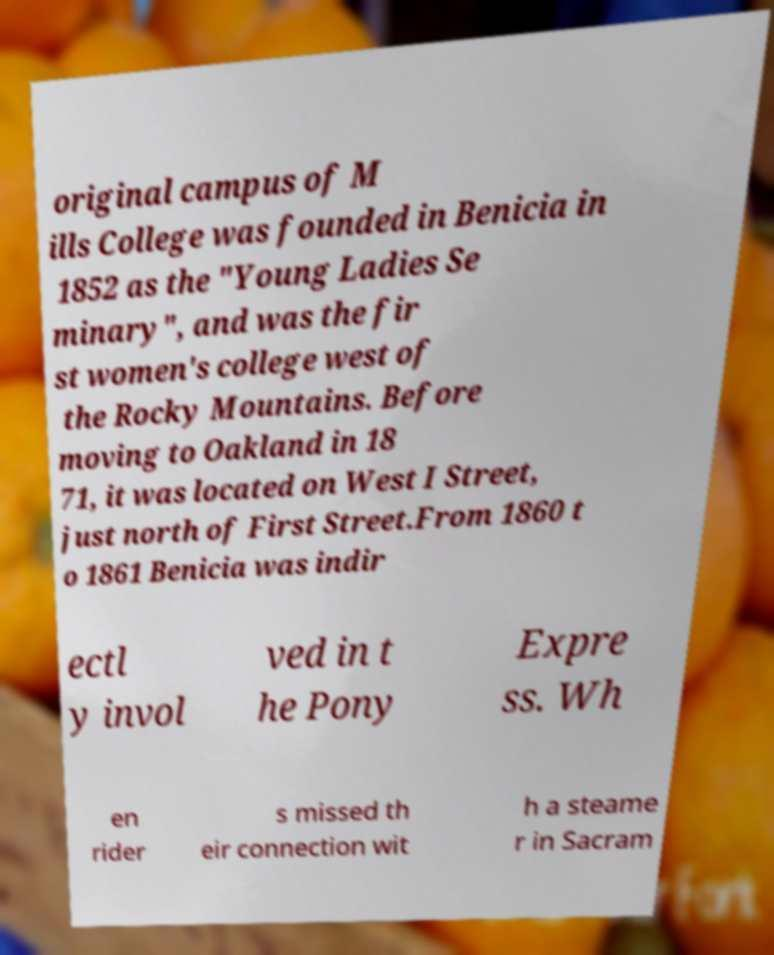There's text embedded in this image that I need extracted. Can you transcribe it verbatim? original campus of M ills College was founded in Benicia in 1852 as the "Young Ladies Se minary", and was the fir st women's college west of the Rocky Mountains. Before moving to Oakland in 18 71, it was located on West I Street, just north of First Street.From 1860 t o 1861 Benicia was indir ectl y invol ved in t he Pony Expre ss. Wh en rider s missed th eir connection wit h a steame r in Sacram 